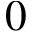<formula> <loc_0><loc_0><loc_500><loc_500>0</formula> 